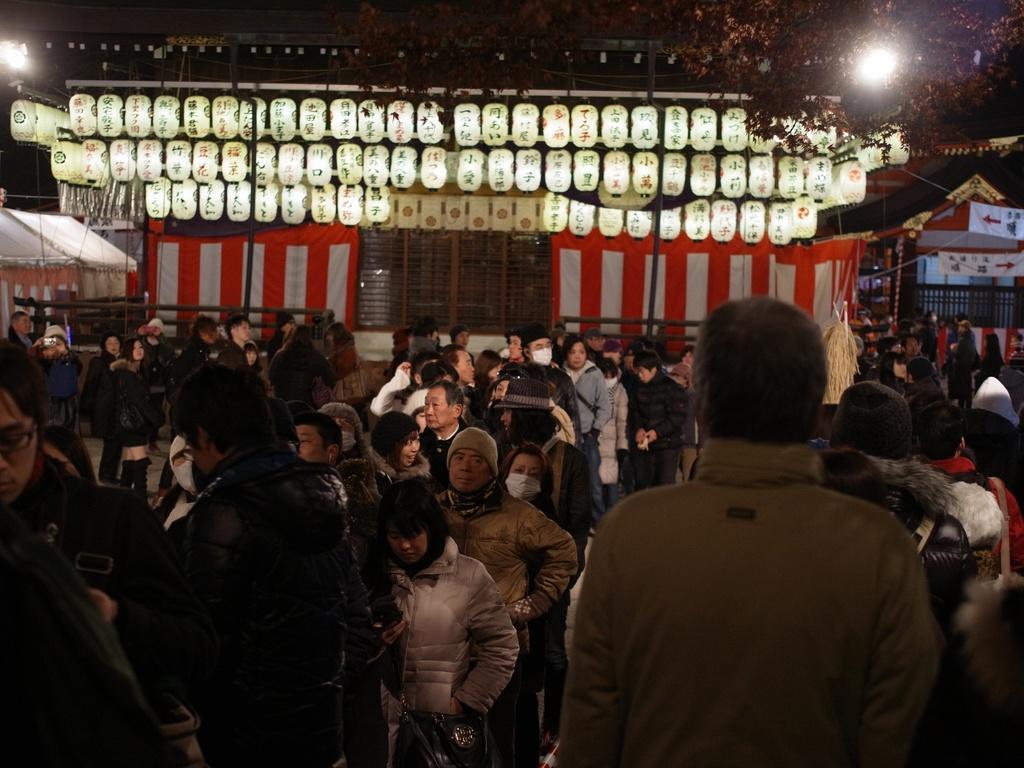Please provide a concise description of this image. In this image there are some persons are standing as we can see in the bottom of this image and there is a building on the top of this image and there are some lights arranged on the top of this image and there is a tree on top right corner of this image. 